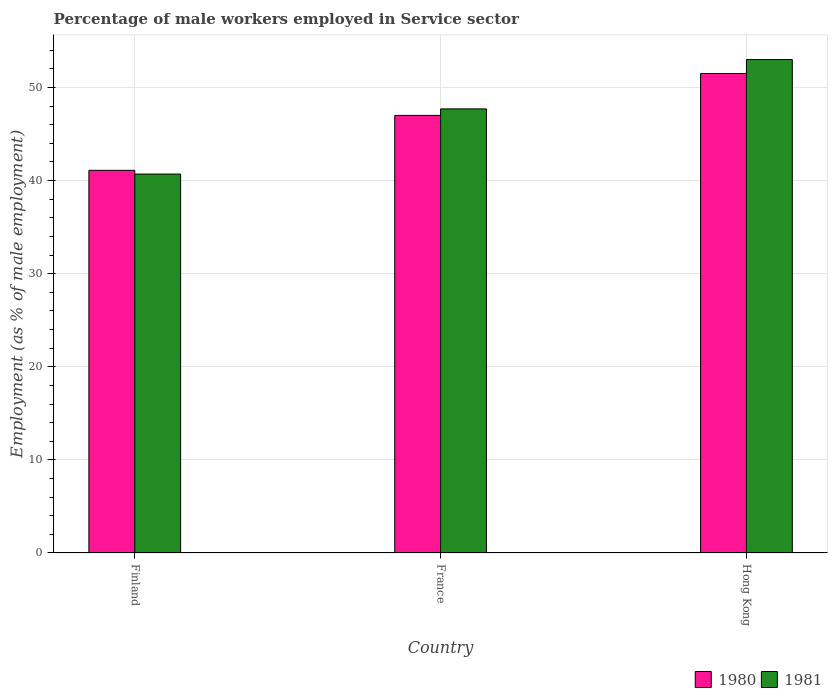Are the number of bars per tick equal to the number of legend labels?
Offer a terse response. Yes. What is the label of the 3rd group of bars from the left?
Your response must be concise. Hong Kong. Across all countries, what is the minimum percentage of male workers employed in Service sector in 1980?
Offer a very short reply. 41.1. In which country was the percentage of male workers employed in Service sector in 1981 maximum?
Your response must be concise. Hong Kong. In which country was the percentage of male workers employed in Service sector in 1981 minimum?
Your answer should be very brief. Finland. What is the total percentage of male workers employed in Service sector in 1980 in the graph?
Provide a short and direct response. 139.6. What is the difference between the percentage of male workers employed in Service sector in 1980 in France and the percentage of male workers employed in Service sector in 1981 in Hong Kong?
Provide a succinct answer. -6. What is the average percentage of male workers employed in Service sector in 1981 per country?
Offer a terse response. 47.13. What is the difference between the percentage of male workers employed in Service sector of/in 1981 and percentage of male workers employed in Service sector of/in 1980 in France?
Offer a terse response. 0.7. In how many countries, is the percentage of male workers employed in Service sector in 1981 greater than 48 %?
Offer a terse response. 1. What is the ratio of the percentage of male workers employed in Service sector in 1981 in Finland to that in France?
Ensure brevity in your answer.  0.85. What is the difference between the highest and the second highest percentage of male workers employed in Service sector in 1981?
Provide a short and direct response. -12.3. What is the difference between the highest and the lowest percentage of male workers employed in Service sector in 1980?
Make the answer very short. 10.4. In how many countries, is the percentage of male workers employed in Service sector in 1981 greater than the average percentage of male workers employed in Service sector in 1981 taken over all countries?
Your answer should be compact. 2. What does the 1st bar from the left in France represents?
Your answer should be compact. 1980. What does the 2nd bar from the right in France represents?
Provide a short and direct response. 1980. Are all the bars in the graph horizontal?
Your answer should be compact. No. How many countries are there in the graph?
Provide a short and direct response. 3. What is the difference between two consecutive major ticks on the Y-axis?
Offer a very short reply. 10. Does the graph contain any zero values?
Your response must be concise. No. Does the graph contain grids?
Offer a terse response. Yes. How many legend labels are there?
Provide a short and direct response. 2. How are the legend labels stacked?
Your answer should be very brief. Horizontal. What is the title of the graph?
Keep it short and to the point. Percentage of male workers employed in Service sector. What is the label or title of the Y-axis?
Give a very brief answer. Employment (as % of male employment). What is the Employment (as % of male employment) in 1980 in Finland?
Offer a very short reply. 41.1. What is the Employment (as % of male employment) in 1981 in Finland?
Ensure brevity in your answer.  40.7. What is the Employment (as % of male employment) of 1981 in France?
Provide a succinct answer. 47.7. What is the Employment (as % of male employment) in 1980 in Hong Kong?
Give a very brief answer. 51.5. Across all countries, what is the maximum Employment (as % of male employment) in 1980?
Ensure brevity in your answer.  51.5. Across all countries, what is the maximum Employment (as % of male employment) in 1981?
Give a very brief answer. 53. Across all countries, what is the minimum Employment (as % of male employment) in 1980?
Ensure brevity in your answer.  41.1. Across all countries, what is the minimum Employment (as % of male employment) in 1981?
Your answer should be very brief. 40.7. What is the total Employment (as % of male employment) in 1980 in the graph?
Give a very brief answer. 139.6. What is the total Employment (as % of male employment) of 1981 in the graph?
Make the answer very short. 141.4. What is the difference between the Employment (as % of male employment) in 1980 in Finland and that in Hong Kong?
Offer a terse response. -10.4. What is the difference between the Employment (as % of male employment) of 1980 in France and that in Hong Kong?
Give a very brief answer. -4.5. What is the difference between the Employment (as % of male employment) in 1981 in France and that in Hong Kong?
Offer a terse response. -5.3. What is the difference between the Employment (as % of male employment) of 1980 in Finland and the Employment (as % of male employment) of 1981 in France?
Make the answer very short. -6.6. What is the difference between the Employment (as % of male employment) of 1980 in Finland and the Employment (as % of male employment) of 1981 in Hong Kong?
Give a very brief answer. -11.9. What is the difference between the Employment (as % of male employment) in 1980 in France and the Employment (as % of male employment) in 1981 in Hong Kong?
Keep it short and to the point. -6. What is the average Employment (as % of male employment) of 1980 per country?
Offer a terse response. 46.53. What is the average Employment (as % of male employment) of 1981 per country?
Ensure brevity in your answer.  47.13. What is the difference between the Employment (as % of male employment) in 1980 and Employment (as % of male employment) in 1981 in Finland?
Give a very brief answer. 0.4. What is the difference between the Employment (as % of male employment) in 1980 and Employment (as % of male employment) in 1981 in France?
Provide a short and direct response. -0.7. What is the difference between the Employment (as % of male employment) in 1980 and Employment (as % of male employment) in 1981 in Hong Kong?
Offer a terse response. -1.5. What is the ratio of the Employment (as % of male employment) of 1980 in Finland to that in France?
Make the answer very short. 0.87. What is the ratio of the Employment (as % of male employment) in 1981 in Finland to that in France?
Your response must be concise. 0.85. What is the ratio of the Employment (as % of male employment) of 1980 in Finland to that in Hong Kong?
Offer a terse response. 0.8. What is the ratio of the Employment (as % of male employment) of 1981 in Finland to that in Hong Kong?
Keep it short and to the point. 0.77. What is the ratio of the Employment (as % of male employment) in 1980 in France to that in Hong Kong?
Your answer should be very brief. 0.91. What is the difference between the highest and the lowest Employment (as % of male employment) in 1981?
Offer a very short reply. 12.3. 